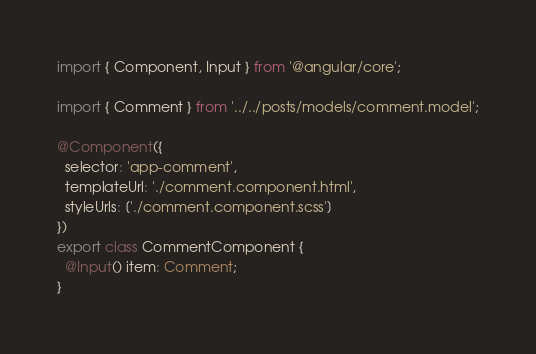Convert code to text. <code><loc_0><loc_0><loc_500><loc_500><_TypeScript_>import { Component, Input } from '@angular/core';

import { Comment } from '../../posts/models/comment.model';

@Component({
  selector: 'app-comment',
  templateUrl: './comment.component.html',
  styleUrls: ['./comment.component.scss']
})
export class CommentComponent {
  @Input() item: Comment;
}
</code> 